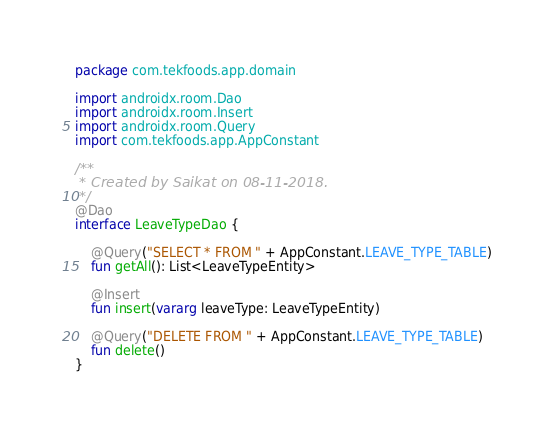Convert code to text. <code><loc_0><loc_0><loc_500><loc_500><_Kotlin_>package com.tekfoods.app.domain

import androidx.room.Dao
import androidx.room.Insert
import androidx.room.Query
import com.tekfoods.app.AppConstant

/**
 * Created by Saikat on 08-11-2018.
 */
@Dao
interface LeaveTypeDao {

    @Query("SELECT * FROM " + AppConstant.LEAVE_TYPE_TABLE)
    fun getAll(): List<LeaveTypeEntity>

    @Insert
    fun insert(vararg leaveType: LeaveTypeEntity)

    @Query("DELETE FROM " + AppConstant.LEAVE_TYPE_TABLE)
    fun delete()
}</code> 